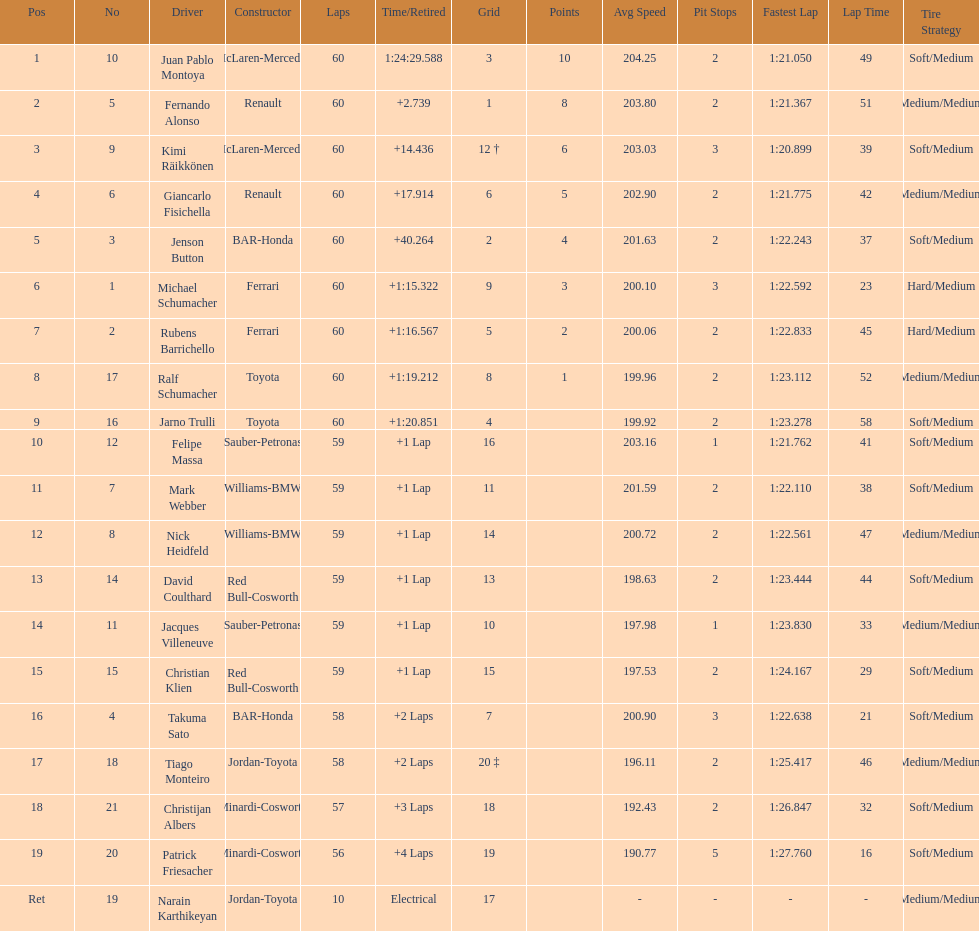After 8th position, how many points does a driver receive? 0. 